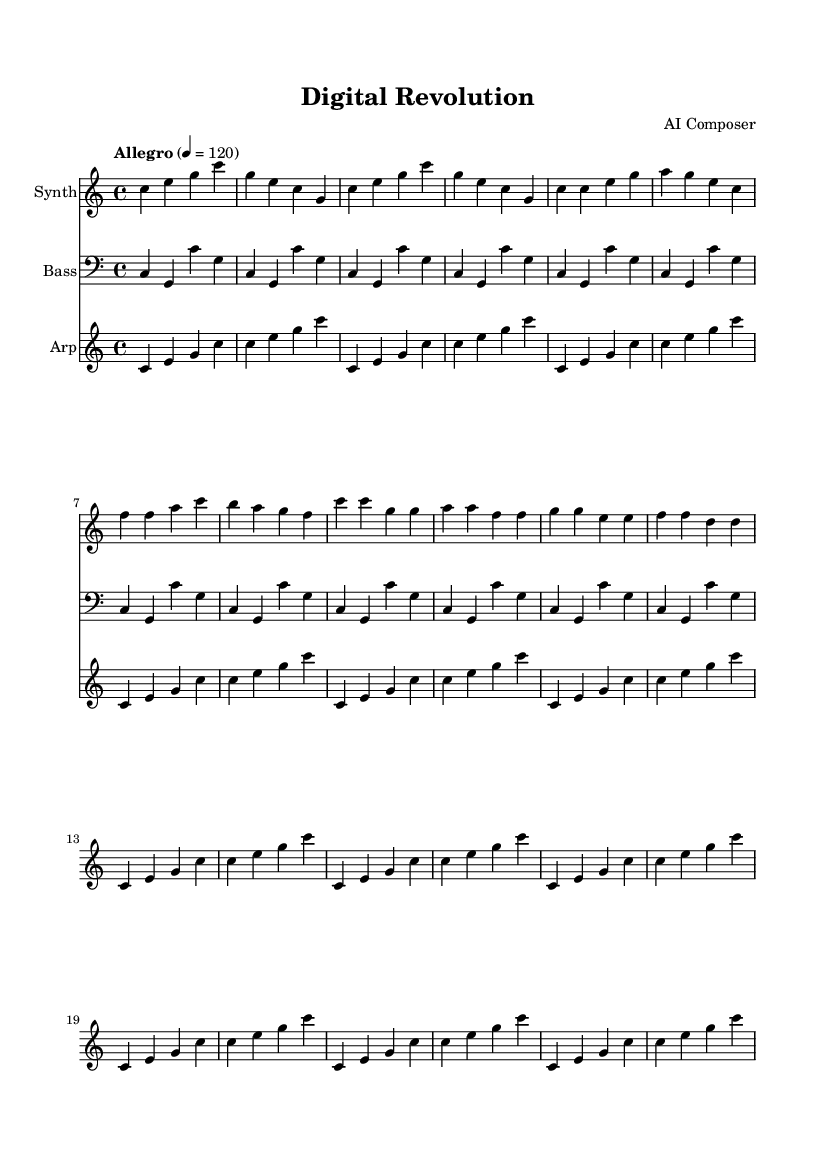What is the key signature of this music? The key signature is C major, which has no sharps or flats.
Answer: C major What is the time signature of this piece? The time signature is indicated at the beginning of the score and is 4/4, which means there are four beats in each measure.
Answer: 4/4 What is the tempo marking for this composition? The tempo marking in the score indicates "Allegro," and the metronome marking specifies 120 beats per minute.
Answer: Allegro, 120 How many measures are in the intro section of this piece? The intro section consists of four measures, as evidenced by the repeated musical phrases. Counting the measures confirms there are four.
Answer: 4 What instrument is labeled for the arpeggiator part? The instrument name provided in the score at the beginning of the staff for the arpeggiator is "Arp."
Answer: Arp How does the bass pattern relate to the main theme? The bass pattern features a consistent repetition with variations with a focus on the notes C and G, reinforcing the harmonic foundation of the synthesizer theme.
Answer: Repetition of C and G Is there a distinct section labeled for the chorus? Yes, the score clearly delineates the chorus section, marked with a contrasting musical phrase compared to the verse and intro.
Answer: Yes 